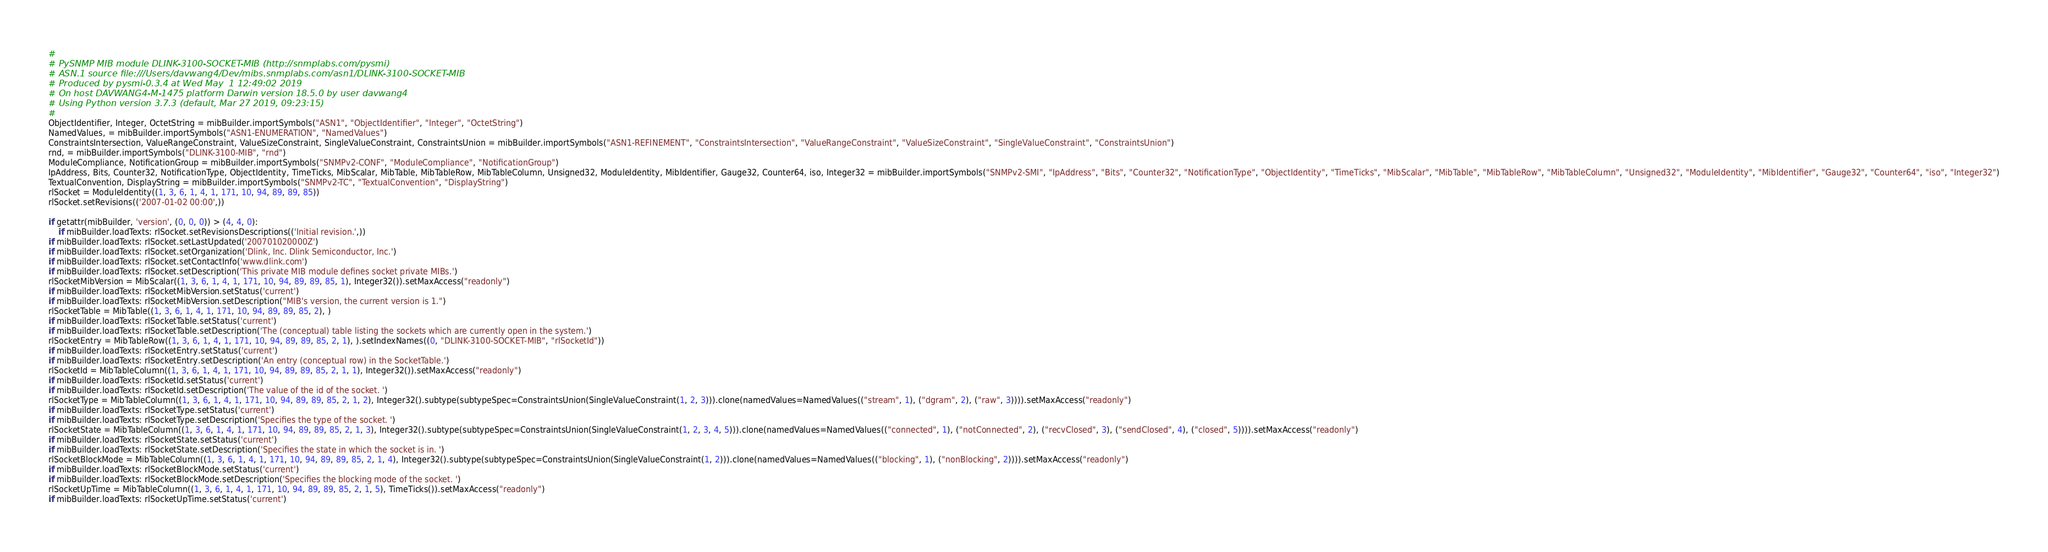Convert code to text. <code><loc_0><loc_0><loc_500><loc_500><_Python_>#
# PySNMP MIB module DLINK-3100-SOCKET-MIB (http://snmplabs.com/pysmi)
# ASN.1 source file:///Users/davwang4/Dev/mibs.snmplabs.com/asn1/DLINK-3100-SOCKET-MIB
# Produced by pysmi-0.3.4 at Wed May  1 12:49:02 2019
# On host DAVWANG4-M-1475 platform Darwin version 18.5.0 by user davwang4
# Using Python version 3.7.3 (default, Mar 27 2019, 09:23:15) 
#
ObjectIdentifier, Integer, OctetString = mibBuilder.importSymbols("ASN1", "ObjectIdentifier", "Integer", "OctetString")
NamedValues, = mibBuilder.importSymbols("ASN1-ENUMERATION", "NamedValues")
ConstraintsIntersection, ValueRangeConstraint, ValueSizeConstraint, SingleValueConstraint, ConstraintsUnion = mibBuilder.importSymbols("ASN1-REFINEMENT", "ConstraintsIntersection", "ValueRangeConstraint", "ValueSizeConstraint", "SingleValueConstraint", "ConstraintsUnion")
rnd, = mibBuilder.importSymbols("DLINK-3100-MIB", "rnd")
ModuleCompliance, NotificationGroup = mibBuilder.importSymbols("SNMPv2-CONF", "ModuleCompliance", "NotificationGroup")
IpAddress, Bits, Counter32, NotificationType, ObjectIdentity, TimeTicks, MibScalar, MibTable, MibTableRow, MibTableColumn, Unsigned32, ModuleIdentity, MibIdentifier, Gauge32, Counter64, iso, Integer32 = mibBuilder.importSymbols("SNMPv2-SMI", "IpAddress", "Bits", "Counter32", "NotificationType", "ObjectIdentity", "TimeTicks", "MibScalar", "MibTable", "MibTableRow", "MibTableColumn", "Unsigned32", "ModuleIdentity", "MibIdentifier", "Gauge32", "Counter64", "iso", "Integer32")
TextualConvention, DisplayString = mibBuilder.importSymbols("SNMPv2-TC", "TextualConvention", "DisplayString")
rlSocket = ModuleIdentity((1, 3, 6, 1, 4, 1, 171, 10, 94, 89, 89, 85))
rlSocket.setRevisions(('2007-01-02 00:00',))

if getattr(mibBuilder, 'version', (0, 0, 0)) > (4, 4, 0):
    if mibBuilder.loadTexts: rlSocket.setRevisionsDescriptions(('Initial revision.',))
if mibBuilder.loadTexts: rlSocket.setLastUpdated('200701020000Z')
if mibBuilder.loadTexts: rlSocket.setOrganization('Dlink, Inc. Dlink Semiconductor, Inc.')
if mibBuilder.loadTexts: rlSocket.setContactInfo('www.dlink.com')
if mibBuilder.loadTexts: rlSocket.setDescription('This private MIB module defines socket private MIBs.')
rlSocketMibVersion = MibScalar((1, 3, 6, 1, 4, 1, 171, 10, 94, 89, 89, 85, 1), Integer32()).setMaxAccess("readonly")
if mibBuilder.loadTexts: rlSocketMibVersion.setStatus('current')
if mibBuilder.loadTexts: rlSocketMibVersion.setDescription("MIB's version, the current version is 1.")
rlSocketTable = MibTable((1, 3, 6, 1, 4, 1, 171, 10, 94, 89, 89, 85, 2), )
if mibBuilder.loadTexts: rlSocketTable.setStatus('current')
if mibBuilder.loadTexts: rlSocketTable.setDescription('The (conceptual) table listing the sockets which are currently open in the system.')
rlSocketEntry = MibTableRow((1, 3, 6, 1, 4, 1, 171, 10, 94, 89, 89, 85, 2, 1), ).setIndexNames((0, "DLINK-3100-SOCKET-MIB", "rlSocketId"))
if mibBuilder.loadTexts: rlSocketEntry.setStatus('current')
if mibBuilder.loadTexts: rlSocketEntry.setDescription('An entry (conceptual row) in the SocketTable.')
rlSocketId = MibTableColumn((1, 3, 6, 1, 4, 1, 171, 10, 94, 89, 89, 85, 2, 1, 1), Integer32()).setMaxAccess("readonly")
if mibBuilder.loadTexts: rlSocketId.setStatus('current')
if mibBuilder.loadTexts: rlSocketId.setDescription('The value of the id of the socket. ')
rlSocketType = MibTableColumn((1, 3, 6, 1, 4, 1, 171, 10, 94, 89, 89, 85, 2, 1, 2), Integer32().subtype(subtypeSpec=ConstraintsUnion(SingleValueConstraint(1, 2, 3))).clone(namedValues=NamedValues(("stream", 1), ("dgram", 2), ("raw", 3)))).setMaxAccess("readonly")
if mibBuilder.loadTexts: rlSocketType.setStatus('current')
if mibBuilder.loadTexts: rlSocketType.setDescription('Specifies the type of the socket. ')
rlSocketState = MibTableColumn((1, 3, 6, 1, 4, 1, 171, 10, 94, 89, 89, 85, 2, 1, 3), Integer32().subtype(subtypeSpec=ConstraintsUnion(SingleValueConstraint(1, 2, 3, 4, 5))).clone(namedValues=NamedValues(("connected", 1), ("notConnected", 2), ("recvClosed", 3), ("sendClosed", 4), ("closed", 5)))).setMaxAccess("readonly")
if mibBuilder.loadTexts: rlSocketState.setStatus('current')
if mibBuilder.loadTexts: rlSocketState.setDescription('Specifies the state in which the socket is in. ')
rlSocketBlockMode = MibTableColumn((1, 3, 6, 1, 4, 1, 171, 10, 94, 89, 89, 85, 2, 1, 4), Integer32().subtype(subtypeSpec=ConstraintsUnion(SingleValueConstraint(1, 2))).clone(namedValues=NamedValues(("blocking", 1), ("nonBlocking", 2)))).setMaxAccess("readonly")
if mibBuilder.loadTexts: rlSocketBlockMode.setStatus('current')
if mibBuilder.loadTexts: rlSocketBlockMode.setDescription('Specifies the blocking mode of the socket. ')
rlSocketUpTime = MibTableColumn((1, 3, 6, 1, 4, 1, 171, 10, 94, 89, 89, 85, 2, 1, 5), TimeTicks()).setMaxAccess("readonly")
if mibBuilder.loadTexts: rlSocketUpTime.setStatus('current')</code> 